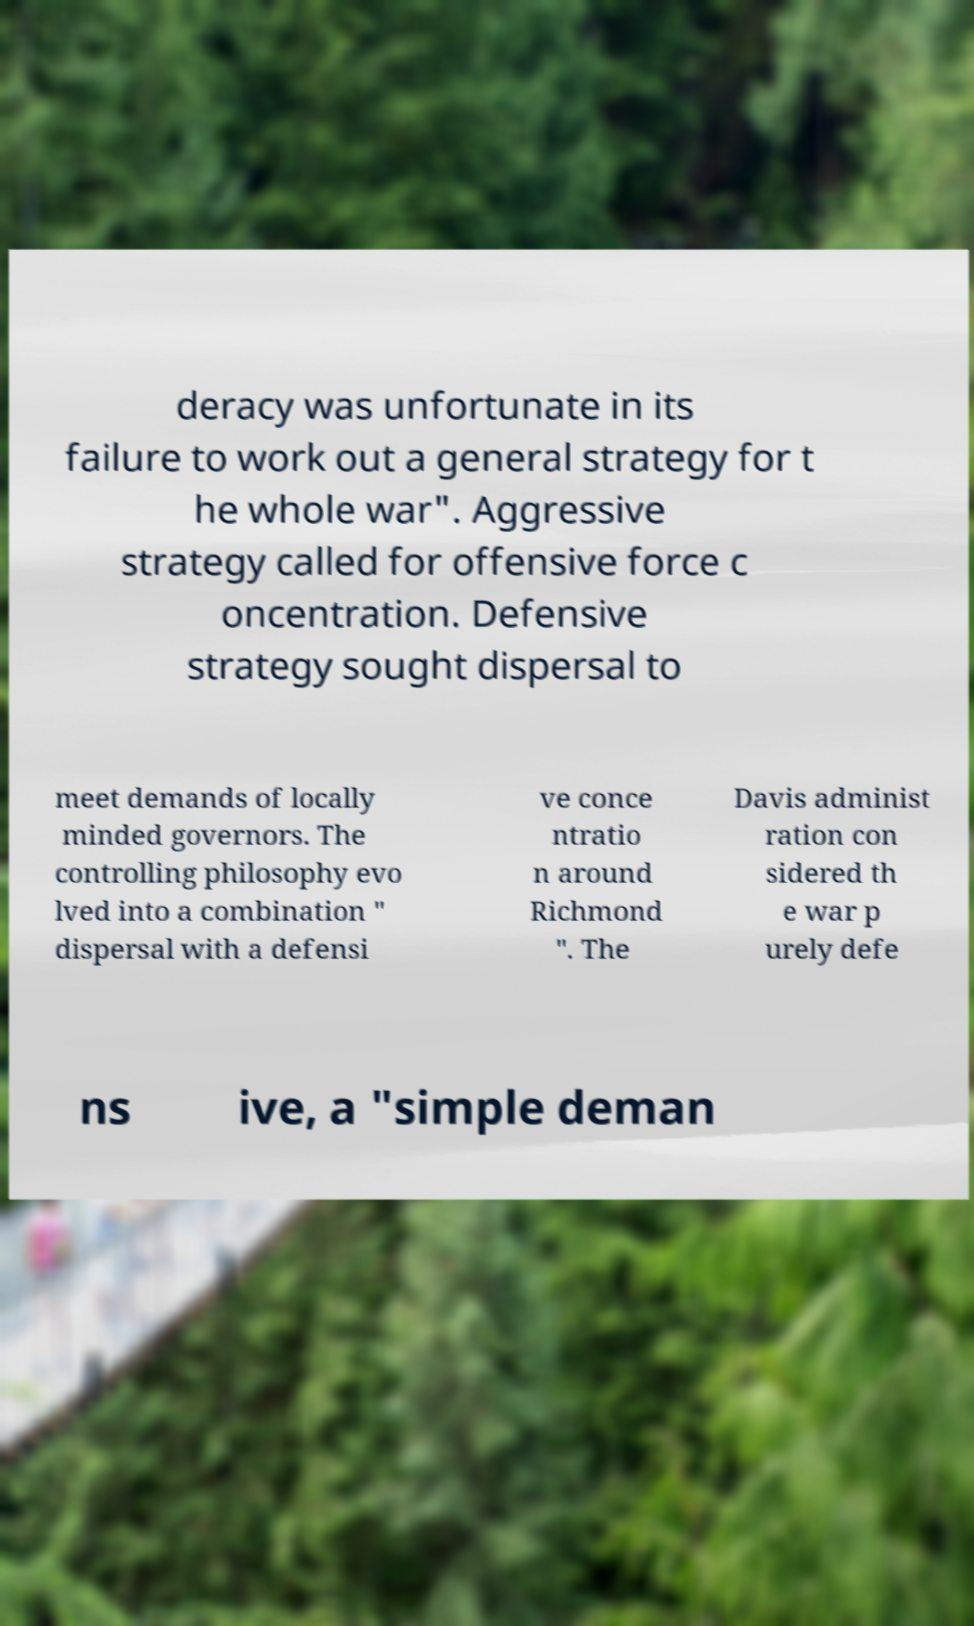There's text embedded in this image that I need extracted. Can you transcribe it verbatim? deracy was unfortunate in its failure to work out a general strategy for t he whole war". Aggressive strategy called for offensive force c oncentration. Defensive strategy sought dispersal to meet demands of locally minded governors. The controlling philosophy evo lved into a combination " dispersal with a defensi ve conce ntratio n around Richmond ". The Davis administ ration con sidered th e war p urely defe ns ive, a "simple deman 